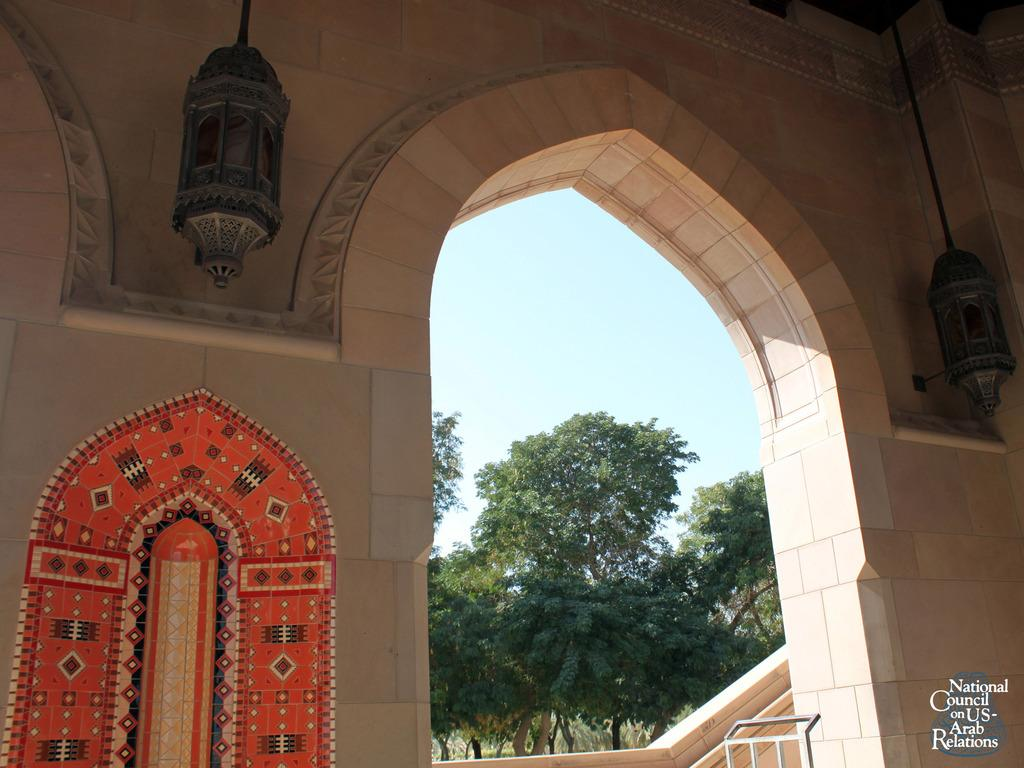What is the main structure visible in the image? There is an entrance arch in the image. What type of lighting is present in the image? Chandeliers are hanging from the top in the image. What type of decorations can be seen on the walls in the image? There are paintings on the wall in the image. What type of natural elements are visible in the image? Trees and the sky are visible in the image. What type of pest can be seen crawling on the paintings in the image? There are no pests visible in the image, and no pests are mentioned in the provided facts. 